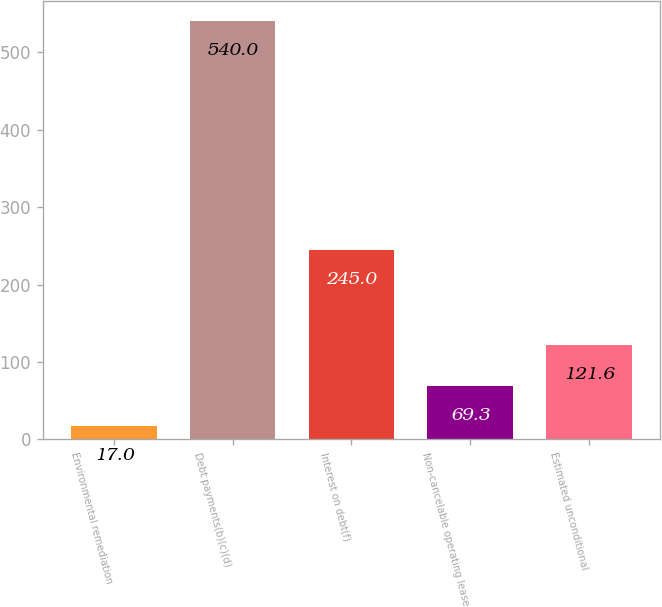<chart> <loc_0><loc_0><loc_500><loc_500><bar_chart><fcel>Environmental remediation<fcel>Debt payments(b)(c)(d)<fcel>Interest on debt(f)<fcel>Non-cancelable operating lease<fcel>Estimated unconditional<nl><fcel>17<fcel>540<fcel>245<fcel>69.3<fcel>121.6<nl></chart> 